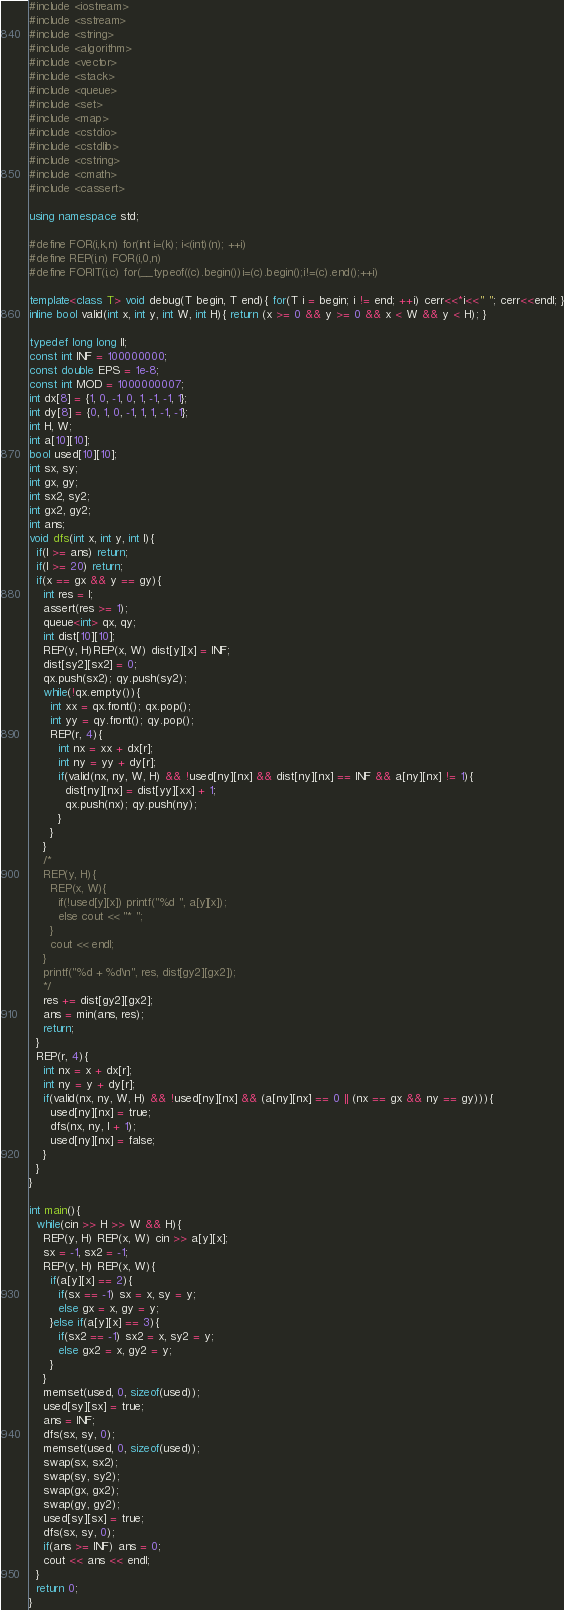<code> <loc_0><loc_0><loc_500><loc_500><_C++_>#include <iostream>
#include <sstream>
#include <string>
#include <algorithm>
#include <vector>
#include <stack>
#include <queue>
#include <set>
#include <map>
#include <cstdio>
#include <cstdlib>
#include <cstring>
#include <cmath>
#include <cassert>

using namespace std;

#define FOR(i,k,n) for(int i=(k); i<(int)(n); ++i)
#define REP(i,n) FOR(i,0,n)
#define FORIT(i,c) for(__typeof((c).begin())i=(c).begin();i!=(c).end();++i)

template<class T> void debug(T begin, T end){ for(T i = begin; i != end; ++i) cerr<<*i<<" "; cerr<<endl; }
inline bool valid(int x, int y, int W, int H){ return (x >= 0 && y >= 0 && x < W && y < H); }

typedef long long ll;
const int INF = 100000000;
const double EPS = 1e-8;
const int MOD = 1000000007;
int dx[8] = {1, 0, -1, 0, 1, -1, -1, 1};
int dy[8] = {0, 1, 0, -1, 1, 1, -1, -1};
int H, W;
int a[10][10];
bool used[10][10];
int sx, sy;
int gx, gy;
int sx2, sy2;
int gx2, gy2;
int ans;
void dfs(int x, int y, int l){
  if(l >= ans) return;
  if(l >= 20) return;
  if(x == gx && y == gy){
    int res = l;
    assert(res >= 1);
    queue<int> qx, qy;
    int dist[10][10];
    REP(y, H)REP(x, W) dist[y][x] = INF;
    dist[sy2][sx2] = 0;
    qx.push(sx2); qy.push(sy2);
    while(!qx.empty()){
      int xx = qx.front(); qx.pop();
      int yy = qy.front(); qy.pop();
      REP(r, 4){
        int nx = xx + dx[r];
        int ny = yy + dy[r];
        if(valid(nx, ny, W, H) && !used[ny][nx] && dist[ny][nx] == INF && a[ny][nx] != 1){
          dist[ny][nx] = dist[yy][xx] + 1;
          qx.push(nx); qy.push(ny);
        }
      }
    }
    /*
    REP(y, H){
      REP(x, W){
        if(!used[y][x]) printf("%d ", a[y][x]);
        else cout << "* ";
      }
      cout << endl;
    }
    printf("%d + %d\n", res, dist[gy2][gx2]);
    */
    res += dist[gy2][gx2];
    ans = min(ans, res);
    return;
  }
  REP(r, 4){
    int nx = x + dx[r];
    int ny = y + dy[r];
    if(valid(nx, ny, W, H) && !used[ny][nx] && (a[ny][nx] == 0 || (nx == gx && ny == gy))){
      used[ny][nx] = true;
      dfs(nx, ny, l + 1);
      used[ny][nx] = false;
    }
  }
}

int main(){
  while(cin >> H >> W && H){
    REP(y, H) REP(x, W) cin >> a[y][x];
    sx = -1, sx2 = -1;
    REP(y, H) REP(x, W){
      if(a[y][x] == 2){
        if(sx == -1) sx = x, sy = y;
        else gx = x, gy = y;
      }else if(a[y][x] == 3){
        if(sx2 == -1) sx2 = x, sy2 = y;
        else gx2 = x, gy2 = y;
      }
    }
    memset(used, 0, sizeof(used));
    used[sy][sx] = true;
    ans = INF;
    dfs(sx, sy, 0);
    memset(used, 0, sizeof(used));
    swap(sx, sx2);
    swap(sy, sy2);
    swap(gx, gx2);
    swap(gy, gy2);
    used[sy][sx] = true;
    dfs(sx, sy, 0);
    if(ans >= INF) ans = 0;
    cout << ans << endl;
  }
  return 0;
}</code> 